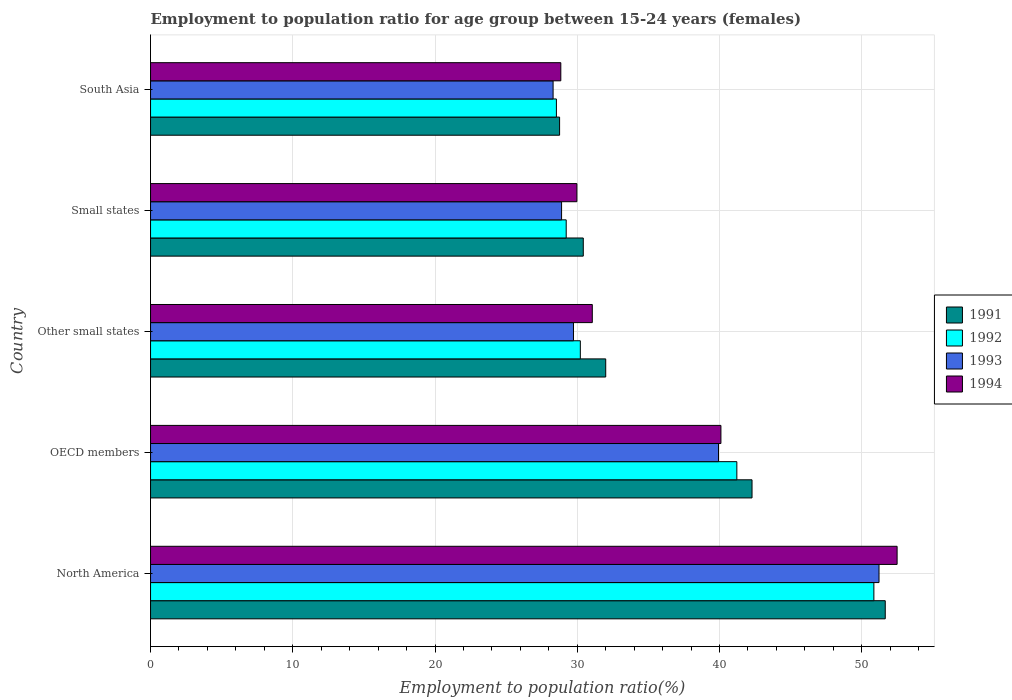How many different coloured bars are there?
Keep it short and to the point. 4. How many groups of bars are there?
Make the answer very short. 5. Are the number of bars per tick equal to the number of legend labels?
Provide a succinct answer. Yes. Are the number of bars on each tick of the Y-axis equal?
Offer a terse response. Yes. How many bars are there on the 3rd tick from the top?
Ensure brevity in your answer.  4. What is the label of the 2nd group of bars from the top?
Keep it short and to the point. Small states. In how many cases, is the number of bars for a given country not equal to the number of legend labels?
Offer a terse response. 0. What is the employment to population ratio in 1992 in OECD members?
Make the answer very short. 41.22. Across all countries, what is the maximum employment to population ratio in 1992?
Make the answer very short. 50.86. Across all countries, what is the minimum employment to population ratio in 1992?
Your answer should be compact. 28.53. In which country was the employment to population ratio in 1993 minimum?
Provide a succinct answer. South Asia. What is the total employment to population ratio in 1994 in the graph?
Give a very brief answer. 182.47. What is the difference between the employment to population ratio in 1994 in North America and that in South Asia?
Make the answer very short. 23.64. What is the difference between the employment to population ratio in 1991 in South Asia and the employment to population ratio in 1993 in OECD members?
Ensure brevity in your answer.  -11.17. What is the average employment to population ratio in 1993 per country?
Make the answer very short. 35.62. What is the difference between the employment to population ratio in 1991 and employment to population ratio in 1993 in North America?
Ensure brevity in your answer.  0.44. What is the ratio of the employment to population ratio in 1994 in Small states to that in South Asia?
Offer a terse response. 1.04. Is the employment to population ratio in 1993 in Other small states less than that in South Asia?
Provide a short and direct response. No. Is the difference between the employment to population ratio in 1991 in Other small states and South Asia greater than the difference between the employment to population ratio in 1993 in Other small states and South Asia?
Provide a short and direct response. Yes. What is the difference between the highest and the second highest employment to population ratio in 1993?
Give a very brief answer. 11.29. What is the difference between the highest and the lowest employment to population ratio in 1994?
Provide a succinct answer. 23.64. In how many countries, is the employment to population ratio in 1994 greater than the average employment to population ratio in 1994 taken over all countries?
Your response must be concise. 2. Is it the case that in every country, the sum of the employment to population ratio in 1994 and employment to population ratio in 1992 is greater than the sum of employment to population ratio in 1991 and employment to population ratio in 1993?
Make the answer very short. No. What does the 1st bar from the bottom in North America represents?
Your answer should be very brief. 1991. How many bars are there?
Keep it short and to the point. 20. Are all the bars in the graph horizontal?
Make the answer very short. Yes. Does the graph contain grids?
Offer a terse response. Yes. How many legend labels are there?
Your answer should be very brief. 4. What is the title of the graph?
Offer a very short reply. Employment to population ratio for age group between 15-24 years (females). What is the Employment to population ratio(%) of 1991 in North America?
Your answer should be very brief. 51.66. What is the Employment to population ratio(%) of 1992 in North America?
Provide a succinct answer. 50.86. What is the Employment to population ratio(%) in 1993 in North America?
Give a very brief answer. 51.22. What is the Employment to population ratio(%) of 1994 in North America?
Ensure brevity in your answer.  52.49. What is the Employment to population ratio(%) in 1991 in OECD members?
Give a very brief answer. 42.29. What is the Employment to population ratio(%) of 1992 in OECD members?
Give a very brief answer. 41.22. What is the Employment to population ratio(%) in 1993 in OECD members?
Give a very brief answer. 39.93. What is the Employment to population ratio(%) of 1994 in OECD members?
Your answer should be very brief. 40.1. What is the Employment to population ratio(%) in 1991 in Other small states?
Make the answer very short. 32. What is the Employment to population ratio(%) in 1992 in Other small states?
Provide a short and direct response. 30.22. What is the Employment to population ratio(%) in 1993 in Other small states?
Provide a short and direct response. 29.74. What is the Employment to population ratio(%) in 1994 in Other small states?
Your answer should be compact. 31.06. What is the Employment to population ratio(%) of 1991 in Small states?
Provide a succinct answer. 30.42. What is the Employment to population ratio(%) of 1992 in Small states?
Offer a very short reply. 29.22. What is the Employment to population ratio(%) of 1993 in Small states?
Make the answer very short. 28.9. What is the Employment to population ratio(%) in 1994 in Small states?
Your answer should be very brief. 29.98. What is the Employment to population ratio(%) of 1991 in South Asia?
Keep it short and to the point. 28.76. What is the Employment to population ratio(%) of 1992 in South Asia?
Offer a terse response. 28.53. What is the Employment to population ratio(%) in 1993 in South Asia?
Your answer should be very brief. 28.3. What is the Employment to population ratio(%) of 1994 in South Asia?
Make the answer very short. 28.85. Across all countries, what is the maximum Employment to population ratio(%) of 1991?
Your answer should be very brief. 51.66. Across all countries, what is the maximum Employment to population ratio(%) of 1992?
Offer a terse response. 50.86. Across all countries, what is the maximum Employment to population ratio(%) of 1993?
Offer a terse response. 51.22. Across all countries, what is the maximum Employment to population ratio(%) in 1994?
Keep it short and to the point. 52.49. Across all countries, what is the minimum Employment to population ratio(%) in 1991?
Offer a terse response. 28.76. Across all countries, what is the minimum Employment to population ratio(%) in 1992?
Offer a terse response. 28.53. Across all countries, what is the minimum Employment to population ratio(%) of 1993?
Offer a very short reply. 28.3. Across all countries, what is the minimum Employment to population ratio(%) in 1994?
Your response must be concise. 28.85. What is the total Employment to population ratio(%) of 1991 in the graph?
Keep it short and to the point. 185.13. What is the total Employment to population ratio(%) of 1992 in the graph?
Ensure brevity in your answer.  180.05. What is the total Employment to population ratio(%) in 1993 in the graph?
Ensure brevity in your answer.  178.09. What is the total Employment to population ratio(%) of 1994 in the graph?
Give a very brief answer. 182.47. What is the difference between the Employment to population ratio(%) of 1991 in North America and that in OECD members?
Your response must be concise. 9.37. What is the difference between the Employment to population ratio(%) of 1992 in North America and that in OECD members?
Your answer should be very brief. 9.63. What is the difference between the Employment to population ratio(%) of 1993 in North America and that in OECD members?
Give a very brief answer. 11.29. What is the difference between the Employment to population ratio(%) of 1994 in North America and that in OECD members?
Provide a succinct answer. 12.39. What is the difference between the Employment to population ratio(%) of 1991 in North America and that in Other small states?
Your answer should be compact. 19.65. What is the difference between the Employment to population ratio(%) in 1992 in North America and that in Other small states?
Your response must be concise. 20.64. What is the difference between the Employment to population ratio(%) in 1993 in North America and that in Other small states?
Your answer should be compact. 21.48. What is the difference between the Employment to population ratio(%) in 1994 in North America and that in Other small states?
Provide a succinct answer. 21.43. What is the difference between the Employment to population ratio(%) of 1991 in North America and that in Small states?
Your answer should be very brief. 21.23. What is the difference between the Employment to population ratio(%) in 1992 in North America and that in Small states?
Keep it short and to the point. 21.63. What is the difference between the Employment to population ratio(%) in 1993 in North America and that in Small states?
Ensure brevity in your answer.  22.32. What is the difference between the Employment to population ratio(%) of 1994 in North America and that in Small states?
Provide a succinct answer. 22.51. What is the difference between the Employment to population ratio(%) of 1991 in North America and that in South Asia?
Give a very brief answer. 22.9. What is the difference between the Employment to population ratio(%) in 1992 in North America and that in South Asia?
Your answer should be compact. 22.32. What is the difference between the Employment to population ratio(%) in 1993 in North America and that in South Asia?
Keep it short and to the point. 22.92. What is the difference between the Employment to population ratio(%) of 1994 in North America and that in South Asia?
Offer a very short reply. 23.64. What is the difference between the Employment to population ratio(%) in 1991 in OECD members and that in Other small states?
Make the answer very short. 10.29. What is the difference between the Employment to population ratio(%) of 1992 in OECD members and that in Other small states?
Ensure brevity in your answer.  11. What is the difference between the Employment to population ratio(%) in 1993 in OECD members and that in Other small states?
Ensure brevity in your answer.  10.2. What is the difference between the Employment to population ratio(%) of 1994 in OECD members and that in Other small states?
Provide a short and direct response. 9.04. What is the difference between the Employment to population ratio(%) of 1991 in OECD members and that in Small states?
Make the answer very short. 11.86. What is the difference between the Employment to population ratio(%) of 1992 in OECD members and that in Small states?
Your answer should be very brief. 12. What is the difference between the Employment to population ratio(%) of 1993 in OECD members and that in Small states?
Offer a terse response. 11.03. What is the difference between the Employment to population ratio(%) of 1994 in OECD members and that in Small states?
Your answer should be compact. 10.13. What is the difference between the Employment to population ratio(%) in 1991 in OECD members and that in South Asia?
Keep it short and to the point. 13.53. What is the difference between the Employment to population ratio(%) of 1992 in OECD members and that in South Asia?
Offer a terse response. 12.69. What is the difference between the Employment to population ratio(%) in 1993 in OECD members and that in South Asia?
Ensure brevity in your answer.  11.63. What is the difference between the Employment to population ratio(%) in 1994 in OECD members and that in South Asia?
Your answer should be very brief. 11.26. What is the difference between the Employment to population ratio(%) in 1991 in Other small states and that in Small states?
Your answer should be very brief. 1.58. What is the difference between the Employment to population ratio(%) in 1992 in Other small states and that in Small states?
Ensure brevity in your answer.  0.99. What is the difference between the Employment to population ratio(%) in 1993 in Other small states and that in Small states?
Offer a very short reply. 0.84. What is the difference between the Employment to population ratio(%) in 1994 in Other small states and that in Small states?
Ensure brevity in your answer.  1.08. What is the difference between the Employment to population ratio(%) in 1991 in Other small states and that in South Asia?
Offer a very short reply. 3.24. What is the difference between the Employment to population ratio(%) of 1992 in Other small states and that in South Asia?
Make the answer very short. 1.68. What is the difference between the Employment to population ratio(%) in 1993 in Other small states and that in South Asia?
Your answer should be compact. 1.43. What is the difference between the Employment to population ratio(%) in 1994 in Other small states and that in South Asia?
Make the answer very short. 2.21. What is the difference between the Employment to population ratio(%) in 1991 in Small states and that in South Asia?
Your response must be concise. 1.67. What is the difference between the Employment to population ratio(%) in 1992 in Small states and that in South Asia?
Give a very brief answer. 0.69. What is the difference between the Employment to population ratio(%) of 1993 in Small states and that in South Asia?
Provide a succinct answer. 0.6. What is the difference between the Employment to population ratio(%) in 1994 in Small states and that in South Asia?
Keep it short and to the point. 1.13. What is the difference between the Employment to population ratio(%) in 1991 in North America and the Employment to population ratio(%) in 1992 in OECD members?
Offer a very short reply. 10.43. What is the difference between the Employment to population ratio(%) of 1991 in North America and the Employment to population ratio(%) of 1993 in OECD members?
Give a very brief answer. 11.72. What is the difference between the Employment to population ratio(%) of 1991 in North America and the Employment to population ratio(%) of 1994 in OECD members?
Provide a succinct answer. 11.55. What is the difference between the Employment to population ratio(%) of 1992 in North America and the Employment to population ratio(%) of 1993 in OECD members?
Your answer should be very brief. 10.92. What is the difference between the Employment to population ratio(%) in 1992 in North America and the Employment to population ratio(%) in 1994 in OECD members?
Offer a terse response. 10.75. What is the difference between the Employment to population ratio(%) of 1993 in North America and the Employment to population ratio(%) of 1994 in OECD members?
Your answer should be very brief. 11.12. What is the difference between the Employment to population ratio(%) in 1991 in North America and the Employment to population ratio(%) in 1992 in Other small states?
Keep it short and to the point. 21.44. What is the difference between the Employment to population ratio(%) in 1991 in North America and the Employment to population ratio(%) in 1993 in Other small states?
Give a very brief answer. 21.92. What is the difference between the Employment to population ratio(%) in 1991 in North America and the Employment to population ratio(%) in 1994 in Other small states?
Your answer should be very brief. 20.6. What is the difference between the Employment to population ratio(%) in 1992 in North America and the Employment to population ratio(%) in 1993 in Other small states?
Your answer should be very brief. 21.12. What is the difference between the Employment to population ratio(%) in 1992 in North America and the Employment to population ratio(%) in 1994 in Other small states?
Provide a short and direct response. 19.8. What is the difference between the Employment to population ratio(%) in 1993 in North America and the Employment to population ratio(%) in 1994 in Other small states?
Offer a terse response. 20.16. What is the difference between the Employment to population ratio(%) in 1991 in North America and the Employment to population ratio(%) in 1992 in Small states?
Make the answer very short. 22.43. What is the difference between the Employment to population ratio(%) in 1991 in North America and the Employment to population ratio(%) in 1993 in Small states?
Ensure brevity in your answer.  22.76. What is the difference between the Employment to population ratio(%) in 1991 in North America and the Employment to population ratio(%) in 1994 in Small states?
Offer a very short reply. 21.68. What is the difference between the Employment to population ratio(%) of 1992 in North America and the Employment to population ratio(%) of 1993 in Small states?
Provide a succinct answer. 21.96. What is the difference between the Employment to population ratio(%) in 1992 in North America and the Employment to population ratio(%) in 1994 in Small states?
Provide a short and direct response. 20.88. What is the difference between the Employment to population ratio(%) in 1993 in North America and the Employment to population ratio(%) in 1994 in Small states?
Provide a succinct answer. 21.24. What is the difference between the Employment to population ratio(%) of 1991 in North America and the Employment to population ratio(%) of 1992 in South Asia?
Ensure brevity in your answer.  23.12. What is the difference between the Employment to population ratio(%) in 1991 in North America and the Employment to population ratio(%) in 1993 in South Asia?
Give a very brief answer. 23.35. What is the difference between the Employment to population ratio(%) of 1991 in North America and the Employment to population ratio(%) of 1994 in South Asia?
Offer a very short reply. 22.81. What is the difference between the Employment to population ratio(%) of 1992 in North America and the Employment to population ratio(%) of 1993 in South Asia?
Your answer should be very brief. 22.55. What is the difference between the Employment to population ratio(%) in 1992 in North America and the Employment to population ratio(%) in 1994 in South Asia?
Offer a terse response. 22.01. What is the difference between the Employment to population ratio(%) in 1993 in North America and the Employment to population ratio(%) in 1994 in South Asia?
Make the answer very short. 22.37. What is the difference between the Employment to population ratio(%) of 1991 in OECD members and the Employment to population ratio(%) of 1992 in Other small states?
Your response must be concise. 12.07. What is the difference between the Employment to population ratio(%) of 1991 in OECD members and the Employment to population ratio(%) of 1993 in Other small states?
Provide a succinct answer. 12.55. What is the difference between the Employment to population ratio(%) of 1991 in OECD members and the Employment to population ratio(%) of 1994 in Other small states?
Your response must be concise. 11.23. What is the difference between the Employment to population ratio(%) of 1992 in OECD members and the Employment to population ratio(%) of 1993 in Other small states?
Offer a terse response. 11.49. What is the difference between the Employment to population ratio(%) in 1992 in OECD members and the Employment to population ratio(%) in 1994 in Other small states?
Provide a short and direct response. 10.16. What is the difference between the Employment to population ratio(%) of 1993 in OECD members and the Employment to population ratio(%) of 1994 in Other small states?
Keep it short and to the point. 8.87. What is the difference between the Employment to population ratio(%) in 1991 in OECD members and the Employment to population ratio(%) in 1992 in Small states?
Offer a terse response. 13.06. What is the difference between the Employment to population ratio(%) in 1991 in OECD members and the Employment to population ratio(%) in 1993 in Small states?
Offer a terse response. 13.39. What is the difference between the Employment to population ratio(%) in 1991 in OECD members and the Employment to population ratio(%) in 1994 in Small states?
Your answer should be compact. 12.31. What is the difference between the Employment to population ratio(%) of 1992 in OECD members and the Employment to population ratio(%) of 1993 in Small states?
Ensure brevity in your answer.  12.32. What is the difference between the Employment to population ratio(%) of 1992 in OECD members and the Employment to population ratio(%) of 1994 in Small states?
Your answer should be very brief. 11.25. What is the difference between the Employment to population ratio(%) of 1993 in OECD members and the Employment to population ratio(%) of 1994 in Small states?
Your answer should be very brief. 9.96. What is the difference between the Employment to population ratio(%) of 1991 in OECD members and the Employment to population ratio(%) of 1992 in South Asia?
Give a very brief answer. 13.75. What is the difference between the Employment to population ratio(%) of 1991 in OECD members and the Employment to population ratio(%) of 1993 in South Asia?
Provide a succinct answer. 13.99. What is the difference between the Employment to population ratio(%) in 1991 in OECD members and the Employment to population ratio(%) in 1994 in South Asia?
Give a very brief answer. 13.44. What is the difference between the Employment to population ratio(%) of 1992 in OECD members and the Employment to population ratio(%) of 1993 in South Asia?
Provide a succinct answer. 12.92. What is the difference between the Employment to population ratio(%) of 1992 in OECD members and the Employment to population ratio(%) of 1994 in South Asia?
Ensure brevity in your answer.  12.38. What is the difference between the Employment to population ratio(%) in 1993 in OECD members and the Employment to population ratio(%) in 1994 in South Asia?
Offer a very short reply. 11.09. What is the difference between the Employment to population ratio(%) in 1991 in Other small states and the Employment to population ratio(%) in 1992 in Small states?
Your answer should be compact. 2.78. What is the difference between the Employment to population ratio(%) in 1991 in Other small states and the Employment to population ratio(%) in 1993 in Small states?
Provide a succinct answer. 3.1. What is the difference between the Employment to population ratio(%) of 1991 in Other small states and the Employment to population ratio(%) of 1994 in Small states?
Provide a short and direct response. 2.03. What is the difference between the Employment to population ratio(%) in 1992 in Other small states and the Employment to population ratio(%) in 1993 in Small states?
Offer a terse response. 1.32. What is the difference between the Employment to population ratio(%) of 1992 in Other small states and the Employment to population ratio(%) of 1994 in Small states?
Make the answer very short. 0.24. What is the difference between the Employment to population ratio(%) in 1993 in Other small states and the Employment to population ratio(%) in 1994 in Small states?
Your answer should be very brief. -0.24. What is the difference between the Employment to population ratio(%) in 1991 in Other small states and the Employment to population ratio(%) in 1992 in South Asia?
Make the answer very short. 3.47. What is the difference between the Employment to population ratio(%) in 1991 in Other small states and the Employment to population ratio(%) in 1993 in South Asia?
Give a very brief answer. 3.7. What is the difference between the Employment to population ratio(%) of 1991 in Other small states and the Employment to population ratio(%) of 1994 in South Asia?
Offer a terse response. 3.16. What is the difference between the Employment to population ratio(%) in 1992 in Other small states and the Employment to population ratio(%) in 1993 in South Asia?
Provide a short and direct response. 1.91. What is the difference between the Employment to population ratio(%) of 1992 in Other small states and the Employment to population ratio(%) of 1994 in South Asia?
Keep it short and to the point. 1.37. What is the difference between the Employment to population ratio(%) of 1993 in Other small states and the Employment to population ratio(%) of 1994 in South Asia?
Ensure brevity in your answer.  0.89. What is the difference between the Employment to population ratio(%) of 1991 in Small states and the Employment to population ratio(%) of 1992 in South Asia?
Your answer should be compact. 1.89. What is the difference between the Employment to population ratio(%) of 1991 in Small states and the Employment to population ratio(%) of 1993 in South Asia?
Your response must be concise. 2.12. What is the difference between the Employment to population ratio(%) of 1991 in Small states and the Employment to population ratio(%) of 1994 in South Asia?
Ensure brevity in your answer.  1.58. What is the difference between the Employment to population ratio(%) of 1992 in Small states and the Employment to population ratio(%) of 1993 in South Asia?
Your answer should be very brief. 0.92. What is the difference between the Employment to population ratio(%) in 1992 in Small states and the Employment to population ratio(%) in 1994 in South Asia?
Keep it short and to the point. 0.38. What is the difference between the Employment to population ratio(%) of 1993 in Small states and the Employment to population ratio(%) of 1994 in South Asia?
Your answer should be very brief. 0.05. What is the average Employment to population ratio(%) of 1991 per country?
Make the answer very short. 37.03. What is the average Employment to population ratio(%) in 1992 per country?
Your answer should be very brief. 36.01. What is the average Employment to population ratio(%) in 1993 per country?
Offer a terse response. 35.62. What is the average Employment to population ratio(%) in 1994 per country?
Make the answer very short. 36.49. What is the difference between the Employment to population ratio(%) of 1991 and Employment to population ratio(%) of 1992 in North America?
Make the answer very short. 0.8. What is the difference between the Employment to population ratio(%) of 1991 and Employment to population ratio(%) of 1993 in North America?
Give a very brief answer. 0.44. What is the difference between the Employment to population ratio(%) in 1991 and Employment to population ratio(%) in 1994 in North America?
Your response must be concise. -0.83. What is the difference between the Employment to population ratio(%) of 1992 and Employment to population ratio(%) of 1993 in North America?
Provide a succinct answer. -0.36. What is the difference between the Employment to population ratio(%) of 1992 and Employment to population ratio(%) of 1994 in North America?
Make the answer very short. -1.63. What is the difference between the Employment to population ratio(%) of 1993 and Employment to population ratio(%) of 1994 in North America?
Your answer should be compact. -1.27. What is the difference between the Employment to population ratio(%) in 1991 and Employment to population ratio(%) in 1992 in OECD members?
Offer a terse response. 1.07. What is the difference between the Employment to population ratio(%) in 1991 and Employment to population ratio(%) in 1993 in OECD members?
Provide a succinct answer. 2.36. What is the difference between the Employment to population ratio(%) in 1991 and Employment to population ratio(%) in 1994 in OECD members?
Provide a succinct answer. 2.19. What is the difference between the Employment to population ratio(%) in 1992 and Employment to population ratio(%) in 1993 in OECD members?
Give a very brief answer. 1.29. What is the difference between the Employment to population ratio(%) in 1992 and Employment to population ratio(%) in 1994 in OECD members?
Give a very brief answer. 1.12. What is the difference between the Employment to population ratio(%) of 1993 and Employment to population ratio(%) of 1994 in OECD members?
Your response must be concise. -0.17. What is the difference between the Employment to population ratio(%) of 1991 and Employment to population ratio(%) of 1992 in Other small states?
Give a very brief answer. 1.79. What is the difference between the Employment to population ratio(%) in 1991 and Employment to population ratio(%) in 1993 in Other small states?
Your response must be concise. 2.27. What is the difference between the Employment to population ratio(%) in 1991 and Employment to population ratio(%) in 1994 in Other small states?
Provide a short and direct response. 0.94. What is the difference between the Employment to population ratio(%) of 1992 and Employment to population ratio(%) of 1993 in Other small states?
Keep it short and to the point. 0.48. What is the difference between the Employment to population ratio(%) in 1992 and Employment to population ratio(%) in 1994 in Other small states?
Provide a short and direct response. -0.84. What is the difference between the Employment to population ratio(%) in 1993 and Employment to population ratio(%) in 1994 in Other small states?
Give a very brief answer. -1.32. What is the difference between the Employment to population ratio(%) in 1991 and Employment to population ratio(%) in 1992 in Small states?
Provide a succinct answer. 1.2. What is the difference between the Employment to population ratio(%) of 1991 and Employment to population ratio(%) of 1993 in Small states?
Offer a very short reply. 1.53. What is the difference between the Employment to population ratio(%) of 1991 and Employment to population ratio(%) of 1994 in Small states?
Offer a terse response. 0.45. What is the difference between the Employment to population ratio(%) of 1992 and Employment to population ratio(%) of 1993 in Small states?
Give a very brief answer. 0.33. What is the difference between the Employment to population ratio(%) in 1992 and Employment to population ratio(%) in 1994 in Small states?
Give a very brief answer. -0.75. What is the difference between the Employment to population ratio(%) in 1993 and Employment to population ratio(%) in 1994 in Small states?
Give a very brief answer. -1.08. What is the difference between the Employment to population ratio(%) in 1991 and Employment to population ratio(%) in 1992 in South Asia?
Ensure brevity in your answer.  0.22. What is the difference between the Employment to population ratio(%) in 1991 and Employment to population ratio(%) in 1993 in South Asia?
Provide a succinct answer. 0.46. What is the difference between the Employment to population ratio(%) of 1991 and Employment to population ratio(%) of 1994 in South Asia?
Offer a terse response. -0.09. What is the difference between the Employment to population ratio(%) of 1992 and Employment to population ratio(%) of 1993 in South Asia?
Your answer should be very brief. 0.23. What is the difference between the Employment to population ratio(%) of 1992 and Employment to population ratio(%) of 1994 in South Asia?
Make the answer very short. -0.31. What is the difference between the Employment to population ratio(%) in 1993 and Employment to population ratio(%) in 1994 in South Asia?
Ensure brevity in your answer.  -0.54. What is the ratio of the Employment to population ratio(%) of 1991 in North America to that in OECD members?
Your answer should be very brief. 1.22. What is the ratio of the Employment to population ratio(%) in 1992 in North America to that in OECD members?
Keep it short and to the point. 1.23. What is the ratio of the Employment to population ratio(%) of 1993 in North America to that in OECD members?
Provide a succinct answer. 1.28. What is the ratio of the Employment to population ratio(%) in 1994 in North America to that in OECD members?
Provide a succinct answer. 1.31. What is the ratio of the Employment to population ratio(%) in 1991 in North America to that in Other small states?
Make the answer very short. 1.61. What is the ratio of the Employment to population ratio(%) in 1992 in North America to that in Other small states?
Keep it short and to the point. 1.68. What is the ratio of the Employment to population ratio(%) in 1993 in North America to that in Other small states?
Offer a terse response. 1.72. What is the ratio of the Employment to population ratio(%) in 1994 in North America to that in Other small states?
Keep it short and to the point. 1.69. What is the ratio of the Employment to population ratio(%) of 1991 in North America to that in Small states?
Keep it short and to the point. 1.7. What is the ratio of the Employment to population ratio(%) of 1992 in North America to that in Small states?
Your response must be concise. 1.74. What is the ratio of the Employment to population ratio(%) of 1993 in North America to that in Small states?
Provide a succinct answer. 1.77. What is the ratio of the Employment to population ratio(%) in 1994 in North America to that in Small states?
Your response must be concise. 1.75. What is the ratio of the Employment to population ratio(%) in 1991 in North America to that in South Asia?
Offer a very short reply. 1.8. What is the ratio of the Employment to population ratio(%) of 1992 in North America to that in South Asia?
Give a very brief answer. 1.78. What is the ratio of the Employment to population ratio(%) of 1993 in North America to that in South Asia?
Your answer should be very brief. 1.81. What is the ratio of the Employment to population ratio(%) in 1994 in North America to that in South Asia?
Provide a short and direct response. 1.82. What is the ratio of the Employment to population ratio(%) of 1991 in OECD members to that in Other small states?
Offer a terse response. 1.32. What is the ratio of the Employment to population ratio(%) of 1992 in OECD members to that in Other small states?
Provide a short and direct response. 1.36. What is the ratio of the Employment to population ratio(%) of 1993 in OECD members to that in Other small states?
Offer a very short reply. 1.34. What is the ratio of the Employment to population ratio(%) in 1994 in OECD members to that in Other small states?
Provide a short and direct response. 1.29. What is the ratio of the Employment to population ratio(%) in 1991 in OECD members to that in Small states?
Ensure brevity in your answer.  1.39. What is the ratio of the Employment to population ratio(%) of 1992 in OECD members to that in Small states?
Provide a succinct answer. 1.41. What is the ratio of the Employment to population ratio(%) of 1993 in OECD members to that in Small states?
Provide a succinct answer. 1.38. What is the ratio of the Employment to population ratio(%) in 1994 in OECD members to that in Small states?
Offer a very short reply. 1.34. What is the ratio of the Employment to population ratio(%) of 1991 in OECD members to that in South Asia?
Offer a terse response. 1.47. What is the ratio of the Employment to population ratio(%) in 1992 in OECD members to that in South Asia?
Your answer should be very brief. 1.44. What is the ratio of the Employment to population ratio(%) of 1993 in OECD members to that in South Asia?
Make the answer very short. 1.41. What is the ratio of the Employment to population ratio(%) of 1994 in OECD members to that in South Asia?
Provide a short and direct response. 1.39. What is the ratio of the Employment to population ratio(%) in 1991 in Other small states to that in Small states?
Offer a terse response. 1.05. What is the ratio of the Employment to population ratio(%) in 1992 in Other small states to that in Small states?
Your response must be concise. 1.03. What is the ratio of the Employment to population ratio(%) in 1993 in Other small states to that in Small states?
Your answer should be compact. 1.03. What is the ratio of the Employment to population ratio(%) in 1994 in Other small states to that in Small states?
Offer a terse response. 1.04. What is the ratio of the Employment to population ratio(%) in 1991 in Other small states to that in South Asia?
Your answer should be compact. 1.11. What is the ratio of the Employment to population ratio(%) of 1992 in Other small states to that in South Asia?
Provide a succinct answer. 1.06. What is the ratio of the Employment to population ratio(%) of 1993 in Other small states to that in South Asia?
Your answer should be compact. 1.05. What is the ratio of the Employment to population ratio(%) in 1994 in Other small states to that in South Asia?
Give a very brief answer. 1.08. What is the ratio of the Employment to population ratio(%) of 1991 in Small states to that in South Asia?
Make the answer very short. 1.06. What is the ratio of the Employment to population ratio(%) in 1992 in Small states to that in South Asia?
Ensure brevity in your answer.  1.02. What is the ratio of the Employment to population ratio(%) of 1993 in Small states to that in South Asia?
Keep it short and to the point. 1.02. What is the ratio of the Employment to population ratio(%) in 1994 in Small states to that in South Asia?
Your answer should be very brief. 1.04. What is the difference between the highest and the second highest Employment to population ratio(%) in 1991?
Keep it short and to the point. 9.37. What is the difference between the highest and the second highest Employment to population ratio(%) in 1992?
Provide a succinct answer. 9.63. What is the difference between the highest and the second highest Employment to population ratio(%) in 1993?
Offer a very short reply. 11.29. What is the difference between the highest and the second highest Employment to population ratio(%) in 1994?
Your answer should be very brief. 12.39. What is the difference between the highest and the lowest Employment to population ratio(%) of 1991?
Give a very brief answer. 22.9. What is the difference between the highest and the lowest Employment to population ratio(%) in 1992?
Ensure brevity in your answer.  22.32. What is the difference between the highest and the lowest Employment to population ratio(%) in 1993?
Offer a terse response. 22.92. What is the difference between the highest and the lowest Employment to population ratio(%) in 1994?
Offer a very short reply. 23.64. 